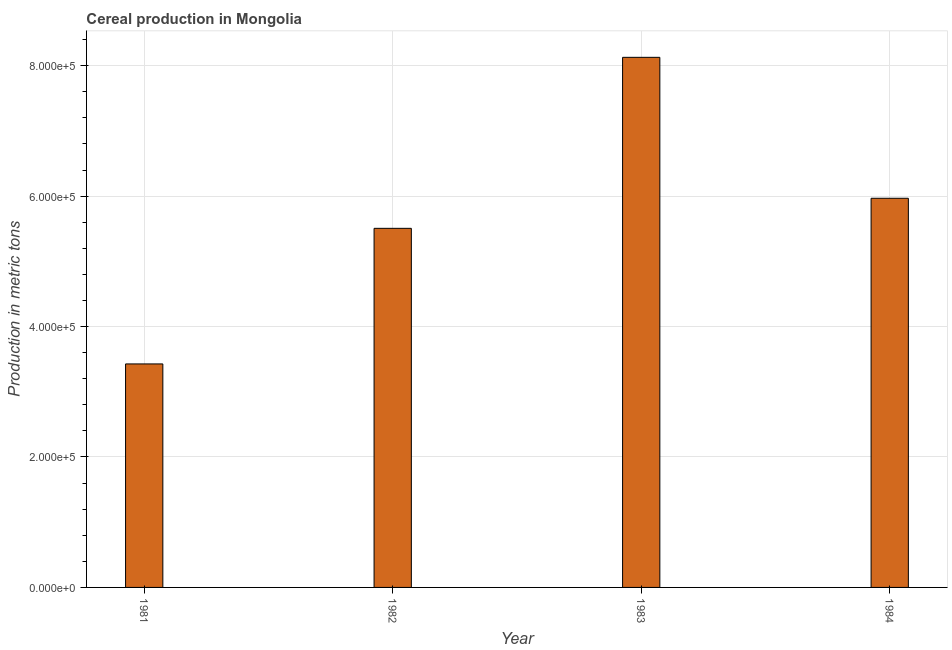Does the graph contain any zero values?
Your answer should be compact. No. Does the graph contain grids?
Provide a short and direct response. Yes. What is the title of the graph?
Make the answer very short. Cereal production in Mongolia. What is the label or title of the Y-axis?
Offer a very short reply. Production in metric tons. What is the cereal production in 1981?
Keep it short and to the point. 3.43e+05. Across all years, what is the maximum cereal production?
Your answer should be compact. 8.13e+05. Across all years, what is the minimum cereal production?
Your answer should be very brief. 3.43e+05. In which year was the cereal production minimum?
Offer a very short reply. 1981. What is the sum of the cereal production?
Offer a terse response. 2.30e+06. What is the difference between the cereal production in 1981 and 1982?
Ensure brevity in your answer.  -2.08e+05. What is the average cereal production per year?
Provide a succinct answer. 5.76e+05. What is the median cereal production?
Your answer should be very brief. 5.74e+05. In how many years, is the cereal production greater than 360000 metric tons?
Offer a very short reply. 3. Do a majority of the years between 1984 and 1983 (inclusive) have cereal production greater than 240000 metric tons?
Offer a very short reply. No. What is the ratio of the cereal production in 1981 to that in 1982?
Your answer should be very brief. 0.62. Is the difference between the cereal production in 1981 and 1983 greater than the difference between any two years?
Your answer should be very brief. Yes. What is the difference between the highest and the second highest cereal production?
Ensure brevity in your answer.  2.16e+05. What is the difference between the highest and the lowest cereal production?
Give a very brief answer. 4.70e+05. How many bars are there?
Your response must be concise. 4. Are all the bars in the graph horizontal?
Your answer should be compact. No. What is the Production in metric tons of 1981?
Your answer should be compact. 3.43e+05. What is the Production in metric tons of 1982?
Offer a very short reply. 5.51e+05. What is the Production in metric tons in 1983?
Give a very brief answer. 8.13e+05. What is the Production in metric tons in 1984?
Your answer should be compact. 5.97e+05. What is the difference between the Production in metric tons in 1981 and 1982?
Offer a very short reply. -2.08e+05. What is the difference between the Production in metric tons in 1981 and 1983?
Your response must be concise. -4.70e+05. What is the difference between the Production in metric tons in 1981 and 1984?
Provide a short and direct response. -2.54e+05. What is the difference between the Production in metric tons in 1982 and 1983?
Offer a very short reply. -2.62e+05. What is the difference between the Production in metric tons in 1982 and 1984?
Keep it short and to the point. -4.61e+04. What is the difference between the Production in metric tons in 1983 and 1984?
Your answer should be very brief. 2.16e+05. What is the ratio of the Production in metric tons in 1981 to that in 1982?
Offer a terse response. 0.62. What is the ratio of the Production in metric tons in 1981 to that in 1983?
Give a very brief answer. 0.42. What is the ratio of the Production in metric tons in 1981 to that in 1984?
Your answer should be compact. 0.57. What is the ratio of the Production in metric tons in 1982 to that in 1983?
Offer a very short reply. 0.68. What is the ratio of the Production in metric tons in 1982 to that in 1984?
Make the answer very short. 0.92. What is the ratio of the Production in metric tons in 1983 to that in 1984?
Give a very brief answer. 1.36. 